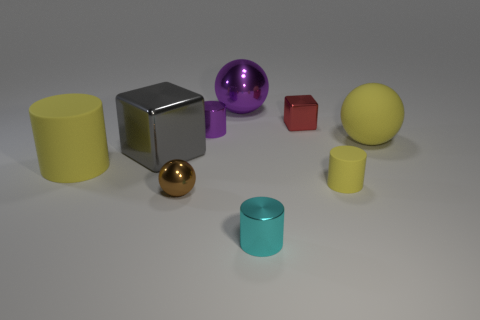Subtract all brown cubes. How many yellow cylinders are left? 2 Subtract all purple cylinders. How many cylinders are left? 3 Subtract all big yellow matte cylinders. How many cylinders are left? 3 Add 1 large brown spheres. How many objects exist? 10 Subtract all blue cylinders. Subtract all red cubes. How many cylinders are left? 4 Subtract all balls. How many objects are left? 6 Add 7 gray matte cylinders. How many gray matte cylinders exist? 7 Subtract 0 yellow blocks. How many objects are left? 9 Subtract all red shiny objects. Subtract all gray metallic blocks. How many objects are left? 7 Add 2 small yellow rubber things. How many small yellow rubber things are left? 3 